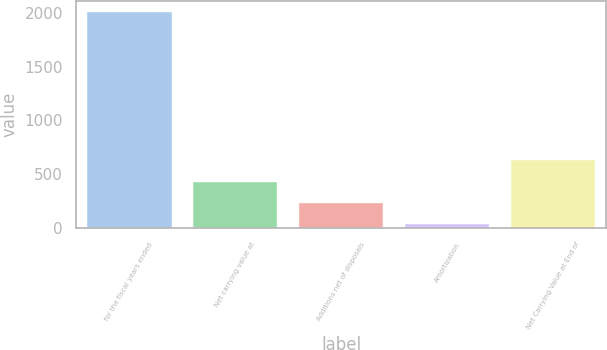Convert chart. <chart><loc_0><loc_0><loc_500><loc_500><bar_chart><fcel>for the fiscal years ended<fcel>Net carrying value at<fcel>Additions net of disposals<fcel>Amortization<fcel>Net Carrying Value at End of<nl><fcel>2011<fcel>431.32<fcel>233.86<fcel>36.4<fcel>628.78<nl></chart> 